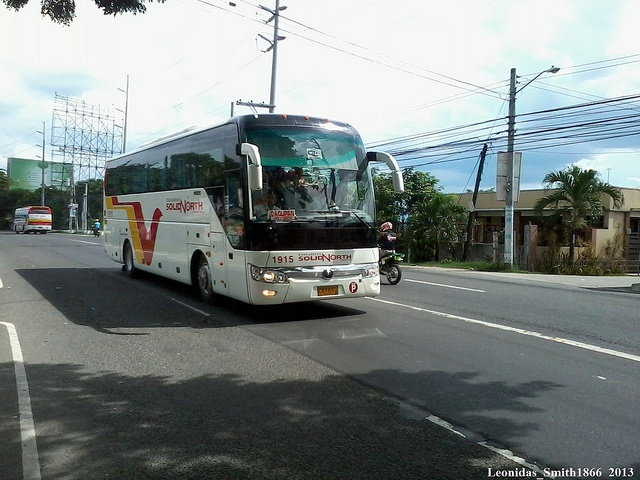Describe the objects in this image and their specific colors. I can see bus in white, black, darkgray, and gray tones, motorcycle in white, black, gray, darkgray, and darkgreen tones, people in white, black, gray, darkgray, and lightgray tones, people in white, black, teal, gray, and lightblue tones, and motorcycle in white, black, gray, darkgray, and lightgray tones in this image. 